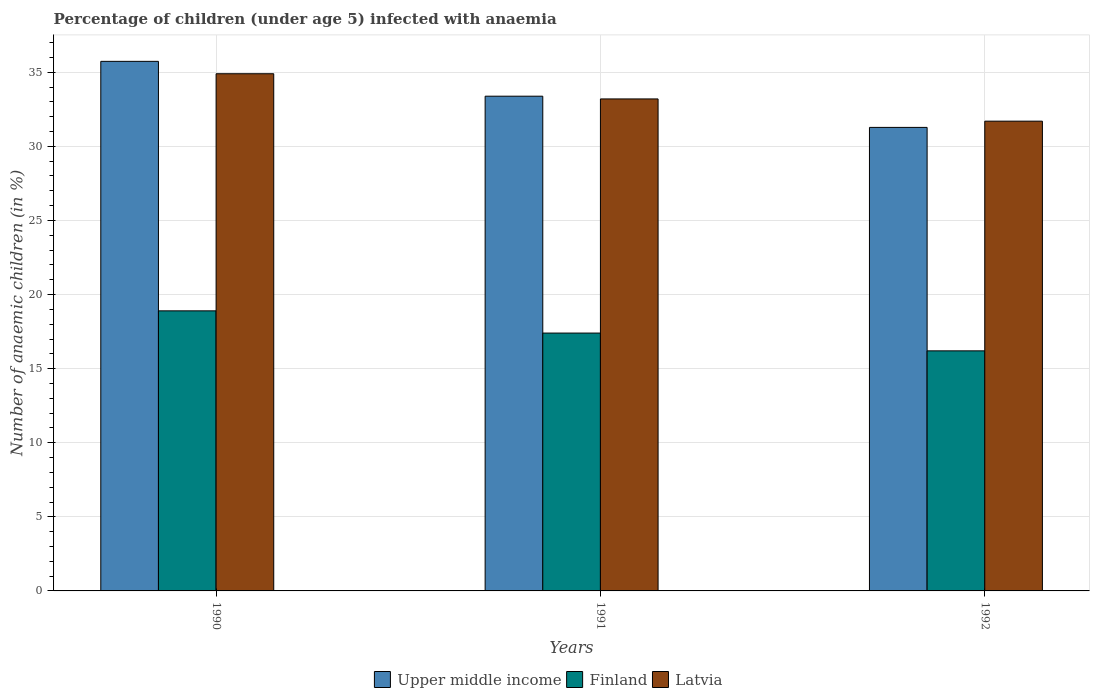Are the number of bars per tick equal to the number of legend labels?
Provide a succinct answer. Yes. Are the number of bars on each tick of the X-axis equal?
Make the answer very short. Yes. What is the label of the 1st group of bars from the left?
Your answer should be compact. 1990. Across all years, what is the maximum percentage of children infected with anaemia in in Finland?
Your answer should be very brief. 18.9. Across all years, what is the minimum percentage of children infected with anaemia in in Finland?
Give a very brief answer. 16.2. In which year was the percentage of children infected with anaemia in in Latvia minimum?
Your answer should be compact. 1992. What is the total percentage of children infected with anaemia in in Latvia in the graph?
Give a very brief answer. 99.8. What is the difference between the percentage of children infected with anaemia in in Latvia in 1990 and that in 1992?
Offer a very short reply. 3.2. What is the difference between the percentage of children infected with anaemia in in Upper middle income in 1991 and the percentage of children infected with anaemia in in Latvia in 1990?
Provide a short and direct response. -1.51. What is the average percentage of children infected with anaemia in in Latvia per year?
Provide a short and direct response. 33.27. In the year 1990, what is the difference between the percentage of children infected with anaemia in in Latvia and percentage of children infected with anaemia in in Upper middle income?
Your answer should be compact. -0.84. In how many years, is the percentage of children infected with anaemia in in Latvia greater than 18 %?
Provide a succinct answer. 3. What is the ratio of the percentage of children infected with anaemia in in Latvia in 1990 to that in 1991?
Your response must be concise. 1.05. What is the difference between the highest and the second highest percentage of children infected with anaemia in in Latvia?
Your response must be concise. 1.7. What is the difference between the highest and the lowest percentage of children infected with anaemia in in Latvia?
Provide a succinct answer. 3.2. Is the sum of the percentage of children infected with anaemia in in Latvia in 1991 and 1992 greater than the maximum percentage of children infected with anaemia in in Finland across all years?
Offer a very short reply. Yes. What does the 1st bar from the left in 1991 represents?
Keep it short and to the point. Upper middle income. What does the 2nd bar from the right in 1990 represents?
Your answer should be compact. Finland. Is it the case that in every year, the sum of the percentage of children infected with anaemia in in Finland and percentage of children infected with anaemia in in Upper middle income is greater than the percentage of children infected with anaemia in in Latvia?
Give a very brief answer. Yes. How many bars are there?
Your response must be concise. 9. Are all the bars in the graph horizontal?
Your response must be concise. No. Does the graph contain grids?
Make the answer very short. Yes. How many legend labels are there?
Offer a terse response. 3. How are the legend labels stacked?
Your answer should be very brief. Horizontal. What is the title of the graph?
Keep it short and to the point. Percentage of children (under age 5) infected with anaemia. What is the label or title of the X-axis?
Provide a succinct answer. Years. What is the label or title of the Y-axis?
Provide a succinct answer. Number of anaemic children (in %). What is the Number of anaemic children (in %) of Upper middle income in 1990?
Your answer should be very brief. 35.74. What is the Number of anaemic children (in %) in Finland in 1990?
Offer a terse response. 18.9. What is the Number of anaemic children (in %) in Latvia in 1990?
Provide a short and direct response. 34.9. What is the Number of anaemic children (in %) of Upper middle income in 1991?
Your response must be concise. 33.39. What is the Number of anaemic children (in %) in Latvia in 1991?
Offer a very short reply. 33.2. What is the Number of anaemic children (in %) of Upper middle income in 1992?
Ensure brevity in your answer.  31.28. What is the Number of anaemic children (in %) in Finland in 1992?
Provide a succinct answer. 16.2. What is the Number of anaemic children (in %) in Latvia in 1992?
Your answer should be compact. 31.7. Across all years, what is the maximum Number of anaemic children (in %) of Upper middle income?
Provide a succinct answer. 35.74. Across all years, what is the maximum Number of anaemic children (in %) of Finland?
Your answer should be very brief. 18.9. Across all years, what is the maximum Number of anaemic children (in %) in Latvia?
Make the answer very short. 34.9. Across all years, what is the minimum Number of anaemic children (in %) in Upper middle income?
Provide a succinct answer. 31.28. Across all years, what is the minimum Number of anaemic children (in %) of Finland?
Your answer should be compact. 16.2. Across all years, what is the minimum Number of anaemic children (in %) of Latvia?
Give a very brief answer. 31.7. What is the total Number of anaemic children (in %) in Upper middle income in the graph?
Your answer should be compact. 100.4. What is the total Number of anaemic children (in %) in Finland in the graph?
Give a very brief answer. 52.5. What is the total Number of anaemic children (in %) of Latvia in the graph?
Offer a terse response. 99.8. What is the difference between the Number of anaemic children (in %) of Upper middle income in 1990 and that in 1991?
Make the answer very short. 2.35. What is the difference between the Number of anaemic children (in %) in Finland in 1990 and that in 1991?
Your response must be concise. 1.5. What is the difference between the Number of anaemic children (in %) of Latvia in 1990 and that in 1991?
Provide a short and direct response. 1.7. What is the difference between the Number of anaemic children (in %) of Upper middle income in 1990 and that in 1992?
Your answer should be very brief. 4.46. What is the difference between the Number of anaemic children (in %) in Latvia in 1990 and that in 1992?
Your response must be concise. 3.2. What is the difference between the Number of anaemic children (in %) in Upper middle income in 1991 and that in 1992?
Keep it short and to the point. 2.11. What is the difference between the Number of anaemic children (in %) of Latvia in 1991 and that in 1992?
Give a very brief answer. 1.5. What is the difference between the Number of anaemic children (in %) of Upper middle income in 1990 and the Number of anaemic children (in %) of Finland in 1991?
Your answer should be compact. 18.34. What is the difference between the Number of anaemic children (in %) of Upper middle income in 1990 and the Number of anaemic children (in %) of Latvia in 1991?
Ensure brevity in your answer.  2.54. What is the difference between the Number of anaemic children (in %) of Finland in 1990 and the Number of anaemic children (in %) of Latvia in 1991?
Your answer should be very brief. -14.3. What is the difference between the Number of anaemic children (in %) of Upper middle income in 1990 and the Number of anaemic children (in %) of Finland in 1992?
Your response must be concise. 19.54. What is the difference between the Number of anaemic children (in %) in Upper middle income in 1990 and the Number of anaemic children (in %) in Latvia in 1992?
Provide a succinct answer. 4.04. What is the difference between the Number of anaemic children (in %) in Finland in 1990 and the Number of anaemic children (in %) in Latvia in 1992?
Provide a short and direct response. -12.8. What is the difference between the Number of anaemic children (in %) of Upper middle income in 1991 and the Number of anaemic children (in %) of Finland in 1992?
Your response must be concise. 17.19. What is the difference between the Number of anaemic children (in %) of Upper middle income in 1991 and the Number of anaemic children (in %) of Latvia in 1992?
Offer a terse response. 1.69. What is the difference between the Number of anaemic children (in %) of Finland in 1991 and the Number of anaemic children (in %) of Latvia in 1992?
Offer a terse response. -14.3. What is the average Number of anaemic children (in %) in Upper middle income per year?
Your answer should be compact. 33.47. What is the average Number of anaemic children (in %) in Finland per year?
Make the answer very short. 17.5. What is the average Number of anaemic children (in %) in Latvia per year?
Ensure brevity in your answer.  33.27. In the year 1990, what is the difference between the Number of anaemic children (in %) in Upper middle income and Number of anaemic children (in %) in Finland?
Your response must be concise. 16.84. In the year 1990, what is the difference between the Number of anaemic children (in %) in Upper middle income and Number of anaemic children (in %) in Latvia?
Offer a terse response. 0.84. In the year 1991, what is the difference between the Number of anaemic children (in %) in Upper middle income and Number of anaemic children (in %) in Finland?
Your answer should be compact. 15.99. In the year 1991, what is the difference between the Number of anaemic children (in %) in Upper middle income and Number of anaemic children (in %) in Latvia?
Provide a short and direct response. 0.19. In the year 1991, what is the difference between the Number of anaemic children (in %) in Finland and Number of anaemic children (in %) in Latvia?
Your answer should be compact. -15.8. In the year 1992, what is the difference between the Number of anaemic children (in %) of Upper middle income and Number of anaemic children (in %) of Finland?
Give a very brief answer. 15.08. In the year 1992, what is the difference between the Number of anaemic children (in %) in Upper middle income and Number of anaemic children (in %) in Latvia?
Provide a succinct answer. -0.42. In the year 1992, what is the difference between the Number of anaemic children (in %) of Finland and Number of anaemic children (in %) of Latvia?
Offer a terse response. -15.5. What is the ratio of the Number of anaemic children (in %) in Upper middle income in 1990 to that in 1991?
Ensure brevity in your answer.  1.07. What is the ratio of the Number of anaemic children (in %) of Finland in 1990 to that in 1991?
Offer a terse response. 1.09. What is the ratio of the Number of anaemic children (in %) in Latvia in 1990 to that in 1991?
Offer a very short reply. 1.05. What is the ratio of the Number of anaemic children (in %) of Upper middle income in 1990 to that in 1992?
Offer a terse response. 1.14. What is the ratio of the Number of anaemic children (in %) of Finland in 1990 to that in 1992?
Provide a succinct answer. 1.17. What is the ratio of the Number of anaemic children (in %) of Latvia in 1990 to that in 1992?
Give a very brief answer. 1.1. What is the ratio of the Number of anaemic children (in %) in Upper middle income in 1991 to that in 1992?
Your answer should be very brief. 1.07. What is the ratio of the Number of anaemic children (in %) in Finland in 1991 to that in 1992?
Your answer should be compact. 1.07. What is the ratio of the Number of anaemic children (in %) of Latvia in 1991 to that in 1992?
Keep it short and to the point. 1.05. What is the difference between the highest and the second highest Number of anaemic children (in %) of Upper middle income?
Offer a very short reply. 2.35. What is the difference between the highest and the lowest Number of anaemic children (in %) of Upper middle income?
Your answer should be very brief. 4.46. What is the difference between the highest and the lowest Number of anaemic children (in %) of Finland?
Ensure brevity in your answer.  2.7. 